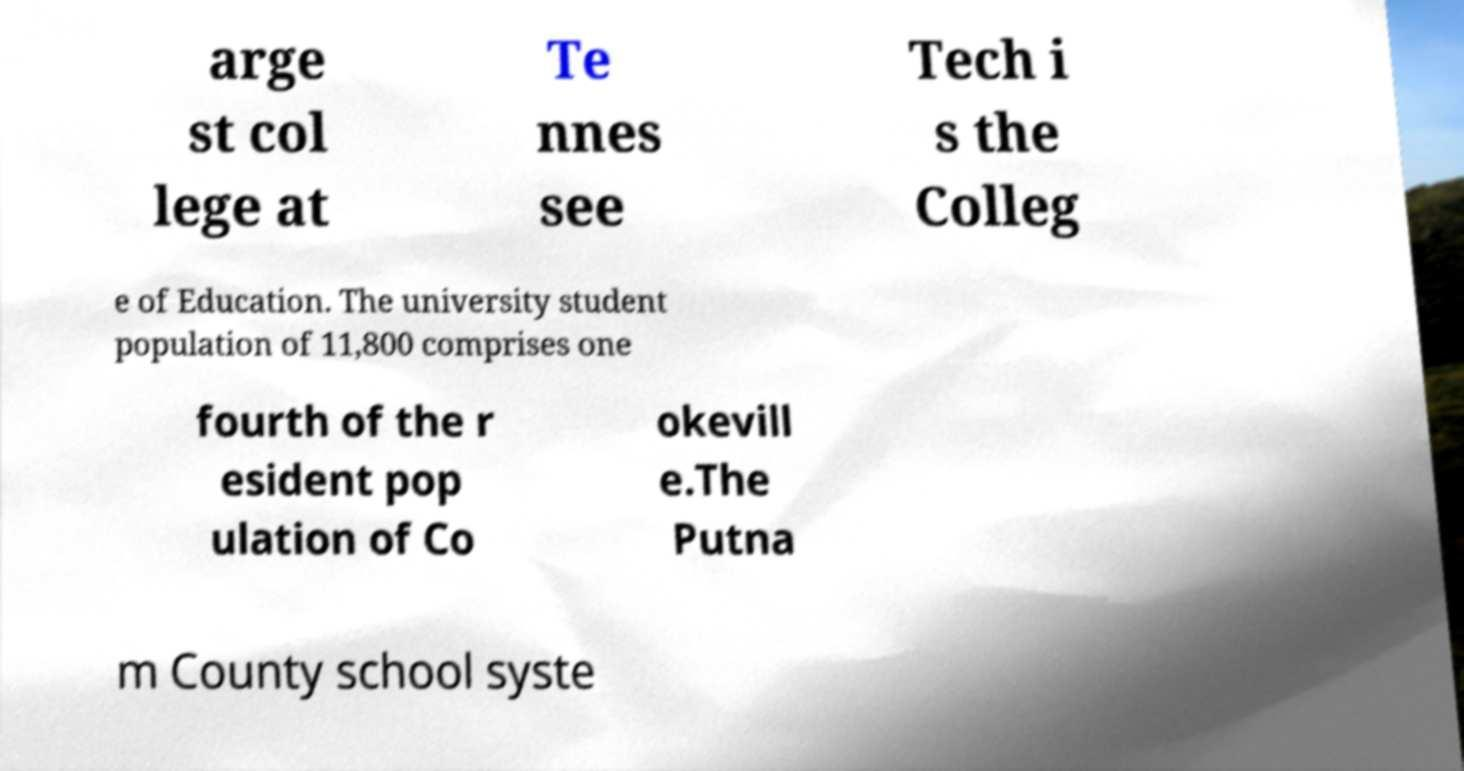What messages or text are displayed in this image? I need them in a readable, typed format. arge st col lege at Te nnes see Tech i s the Colleg e of Education. The university student population of 11,800 comprises one fourth of the r esident pop ulation of Co okevill e.The Putna m County school syste 